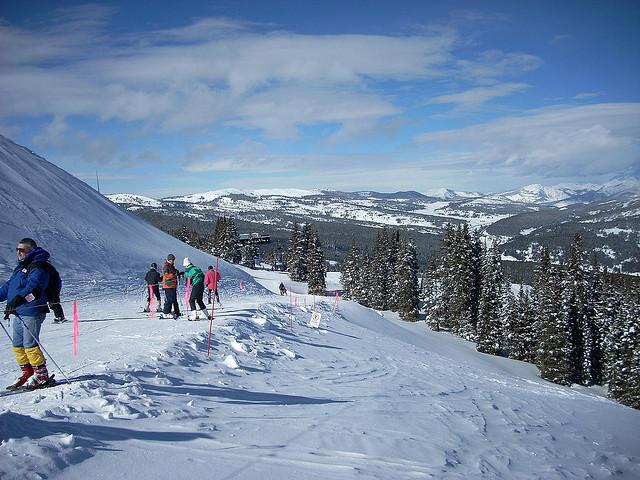Why are pink ribbons tied on the string? visibility 